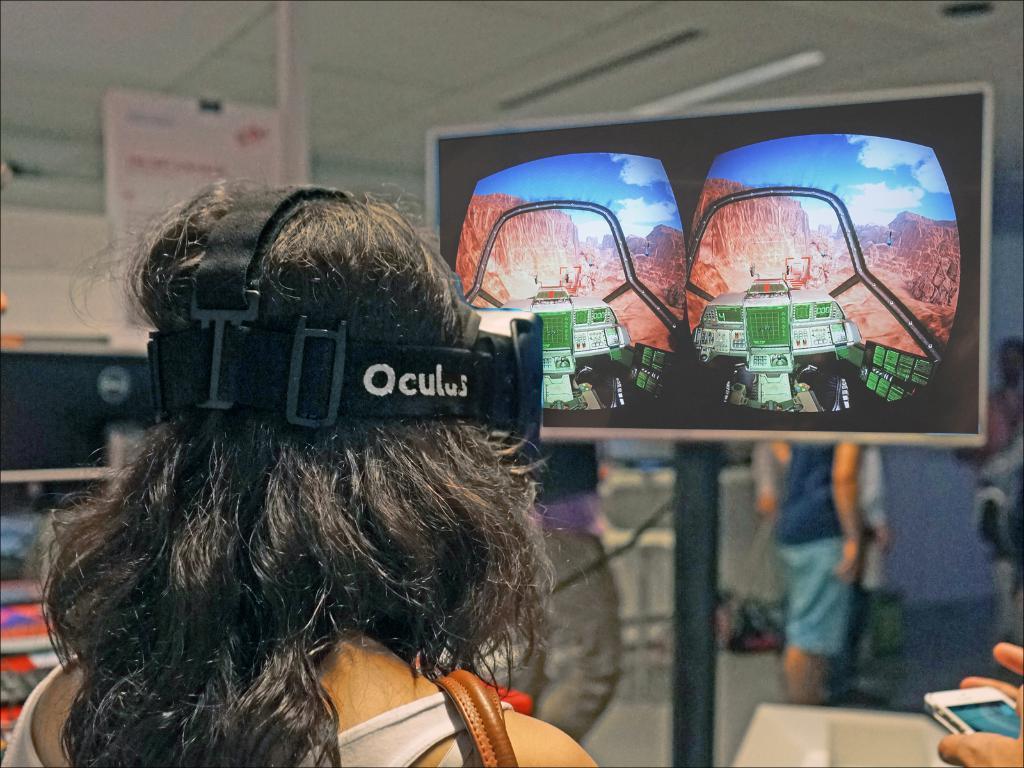Please provide a concise description of this image. In this picture we can see a person wearing a black object on the head. We can see some text on the black object. There is a phone visible in the hands of a person in the bottom right. We can see screen a few people and other objects in the background. Background is blurry. 